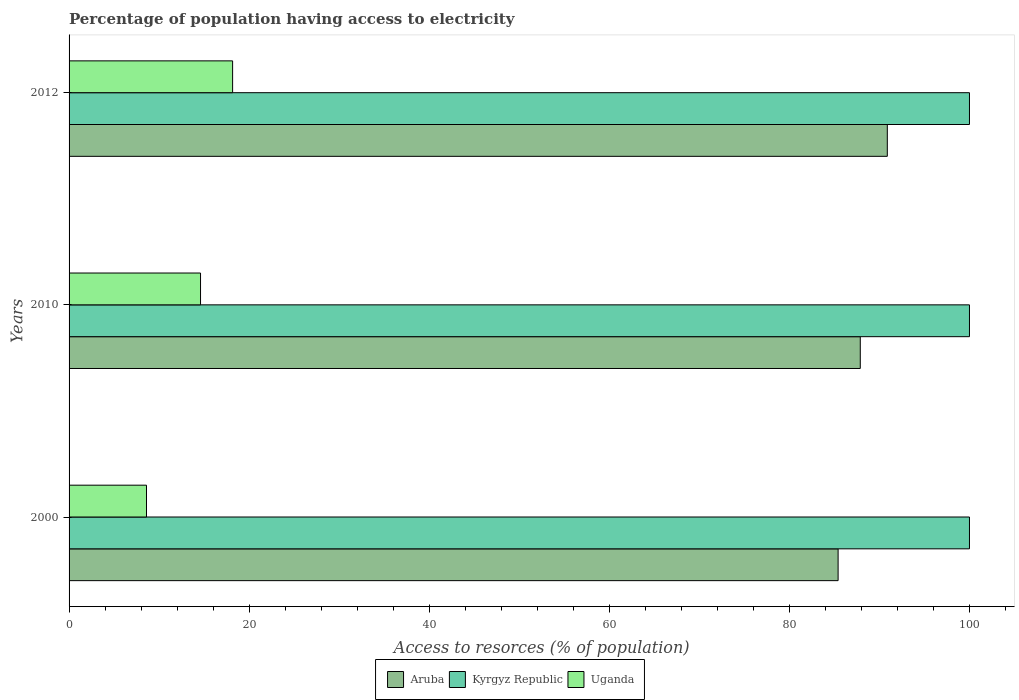How many groups of bars are there?
Provide a succinct answer. 3. Are the number of bars on each tick of the Y-axis equal?
Your response must be concise. Yes. How many bars are there on the 2nd tick from the top?
Provide a succinct answer. 3. How many bars are there on the 3rd tick from the bottom?
Offer a very short reply. 3. What is the label of the 1st group of bars from the top?
Your answer should be very brief. 2012. In how many cases, is the number of bars for a given year not equal to the number of legend labels?
Offer a terse response. 0. What is the percentage of population having access to electricity in Uganda in 2010?
Your answer should be compact. 14.6. Across all years, what is the maximum percentage of population having access to electricity in Uganda?
Keep it short and to the point. 18.16. In which year was the percentage of population having access to electricity in Aruba maximum?
Your answer should be compact. 2012. What is the total percentage of population having access to electricity in Kyrgyz Republic in the graph?
Offer a terse response. 300. What is the difference between the percentage of population having access to electricity in Aruba in 2000 and that in 2012?
Keep it short and to the point. -5.46. What is the difference between the percentage of population having access to electricity in Aruba in 2010 and the percentage of population having access to electricity in Uganda in 2012?
Provide a short and direct response. 69.71. What is the average percentage of population having access to electricity in Kyrgyz Republic per year?
Keep it short and to the point. 100. In the year 2010, what is the difference between the percentage of population having access to electricity in Uganda and percentage of population having access to electricity in Aruba?
Make the answer very short. -73.27. What is the ratio of the percentage of population having access to electricity in Uganda in 2000 to that in 2010?
Provide a short and direct response. 0.59. Is the percentage of population having access to electricity in Uganda in 2000 less than that in 2012?
Offer a very short reply. Yes. Is the difference between the percentage of population having access to electricity in Uganda in 2010 and 2012 greater than the difference between the percentage of population having access to electricity in Aruba in 2010 and 2012?
Offer a terse response. No. What is the difference between the highest and the second highest percentage of population having access to electricity in Aruba?
Your response must be concise. 3. What is the difference between the highest and the lowest percentage of population having access to electricity in Kyrgyz Republic?
Provide a short and direct response. 0. Is the sum of the percentage of population having access to electricity in Kyrgyz Republic in 2000 and 2010 greater than the maximum percentage of population having access to electricity in Aruba across all years?
Your answer should be very brief. Yes. What does the 3rd bar from the top in 2012 represents?
Your answer should be compact. Aruba. What does the 1st bar from the bottom in 2010 represents?
Provide a succinct answer. Aruba. Is it the case that in every year, the sum of the percentage of population having access to electricity in Uganda and percentage of population having access to electricity in Aruba is greater than the percentage of population having access to electricity in Kyrgyz Republic?
Give a very brief answer. No. How many bars are there?
Ensure brevity in your answer.  9. How many years are there in the graph?
Your response must be concise. 3. Are the values on the major ticks of X-axis written in scientific E-notation?
Your answer should be very brief. No. Does the graph contain any zero values?
Your answer should be compact. No. Does the graph contain grids?
Your response must be concise. No. Where does the legend appear in the graph?
Your response must be concise. Bottom center. How many legend labels are there?
Offer a terse response. 3. What is the title of the graph?
Offer a very short reply. Percentage of population having access to electricity. Does "Lebanon" appear as one of the legend labels in the graph?
Offer a terse response. No. What is the label or title of the X-axis?
Provide a short and direct response. Access to resorces (% of population). What is the Access to resorces (% of population) in Aruba in 2000?
Provide a short and direct response. 85.41. What is the Access to resorces (% of population) in Aruba in 2010?
Your response must be concise. 87.87. What is the Access to resorces (% of population) in Kyrgyz Republic in 2010?
Provide a succinct answer. 100. What is the Access to resorces (% of population) in Aruba in 2012?
Offer a terse response. 90.88. What is the Access to resorces (% of population) of Uganda in 2012?
Ensure brevity in your answer.  18.16. Across all years, what is the maximum Access to resorces (% of population) in Aruba?
Provide a short and direct response. 90.88. Across all years, what is the maximum Access to resorces (% of population) of Uganda?
Your answer should be compact. 18.16. Across all years, what is the minimum Access to resorces (% of population) in Aruba?
Provide a succinct answer. 85.41. Across all years, what is the minimum Access to resorces (% of population) in Uganda?
Offer a very short reply. 8.6. What is the total Access to resorces (% of population) in Aruba in the graph?
Your response must be concise. 264.16. What is the total Access to resorces (% of population) in Kyrgyz Republic in the graph?
Your answer should be very brief. 300. What is the total Access to resorces (% of population) in Uganda in the graph?
Give a very brief answer. 41.36. What is the difference between the Access to resorces (% of population) of Aruba in 2000 and that in 2010?
Your answer should be very brief. -2.46. What is the difference between the Access to resorces (% of population) of Uganda in 2000 and that in 2010?
Keep it short and to the point. -6. What is the difference between the Access to resorces (% of population) in Aruba in 2000 and that in 2012?
Your answer should be very brief. -5.46. What is the difference between the Access to resorces (% of population) in Uganda in 2000 and that in 2012?
Give a very brief answer. -9.56. What is the difference between the Access to resorces (% of population) of Aruba in 2010 and that in 2012?
Your answer should be compact. -3. What is the difference between the Access to resorces (% of population) of Kyrgyz Republic in 2010 and that in 2012?
Your answer should be compact. 0. What is the difference between the Access to resorces (% of population) in Uganda in 2010 and that in 2012?
Offer a very short reply. -3.56. What is the difference between the Access to resorces (% of population) in Aruba in 2000 and the Access to resorces (% of population) in Kyrgyz Republic in 2010?
Provide a short and direct response. -14.59. What is the difference between the Access to resorces (% of population) in Aruba in 2000 and the Access to resorces (% of population) in Uganda in 2010?
Ensure brevity in your answer.  70.81. What is the difference between the Access to resorces (% of population) in Kyrgyz Republic in 2000 and the Access to resorces (% of population) in Uganda in 2010?
Your response must be concise. 85.4. What is the difference between the Access to resorces (% of population) of Aruba in 2000 and the Access to resorces (% of population) of Kyrgyz Republic in 2012?
Provide a succinct answer. -14.59. What is the difference between the Access to resorces (% of population) of Aruba in 2000 and the Access to resorces (% of population) of Uganda in 2012?
Keep it short and to the point. 67.25. What is the difference between the Access to resorces (% of population) in Kyrgyz Republic in 2000 and the Access to resorces (% of population) in Uganda in 2012?
Offer a terse response. 81.84. What is the difference between the Access to resorces (% of population) in Aruba in 2010 and the Access to resorces (% of population) in Kyrgyz Republic in 2012?
Give a very brief answer. -12.13. What is the difference between the Access to resorces (% of population) in Aruba in 2010 and the Access to resorces (% of population) in Uganda in 2012?
Give a very brief answer. 69.71. What is the difference between the Access to resorces (% of population) in Kyrgyz Republic in 2010 and the Access to resorces (% of population) in Uganda in 2012?
Your answer should be compact. 81.84. What is the average Access to resorces (% of population) of Aruba per year?
Your answer should be very brief. 88.05. What is the average Access to resorces (% of population) in Kyrgyz Republic per year?
Ensure brevity in your answer.  100. What is the average Access to resorces (% of population) in Uganda per year?
Your response must be concise. 13.79. In the year 2000, what is the difference between the Access to resorces (% of population) of Aruba and Access to resorces (% of population) of Kyrgyz Republic?
Provide a succinct answer. -14.59. In the year 2000, what is the difference between the Access to resorces (% of population) in Aruba and Access to resorces (% of population) in Uganda?
Give a very brief answer. 76.81. In the year 2000, what is the difference between the Access to resorces (% of population) of Kyrgyz Republic and Access to resorces (% of population) of Uganda?
Make the answer very short. 91.4. In the year 2010, what is the difference between the Access to resorces (% of population) of Aruba and Access to resorces (% of population) of Kyrgyz Republic?
Your response must be concise. -12.13. In the year 2010, what is the difference between the Access to resorces (% of population) in Aruba and Access to resorces (% of population) in Uganda?
Give a very brief answer. 73.27. In the year 2010, what is the difference between the Access to resorces (% of population) of Kyrgyz Republic and Access to resorces (% of population) of Uganda?
Ensure brevity in your answer.  85.4. In the year 2012, what is the difference between the Access to resorces (% of population) of Aruba and Access to resorces (% of population) of Kyrgyz Republic?
Your answer should be compact. -9.12. In the year 2012, what is the difference between the Access to resorces (% of population) of Aruba and Access to resorces (% of population) of Uganda?
Your answer should be compact. 72.71. In the year 2012, what is the difference between the Access to resorces (% of population) of Kyrgyz Republic and Access to resorces (% of population) of Uganda?
Your response must be concise. 81.84. What is the ratio of the Access to resorces (% of population) of Aruba in 2000 to that in 2010?
Ensure brevity in your answer.  0.97. What is the ratio of the Access to resorces (% of population) in Kyrgyz Republic in 2000 to that in 2010?
Make the answer very short. 1. What is the ratio of the Access to resorces (% of population) in Uganda in 2000 to that in 2010?
Your response must be concise. 0.59. What is the ratio of the Access to resorces (% of population) in Aruba in 2000 to that in 2012?
Your response must be concise. 0.94. What is the ratio of the Access to resorces (% of population) in Uganda in 2000 to that in 2012?
Ensure brevity in your answer.  0.47. What is the ratio of the Access to resorces (% of population) in Uganda in 2010 to that in 2012?
Keep it short and to the point. 0.8. What is the difference between the highest and the second highest Access to resorces (% of population) of Aruba?
Provide a short and direct response. 3. What is the difference between the highest and the second highest Access to resorces (% of population) in Uganda?
Offer a very short reply. 3.56. What is the difference between the highest and the lowest Access to resorces (% of population) of Aruba?
Offer a very short reply. 5.46. What is the difference between the highest and the lowest Access to resorces (% of population) of Kyrgyz Republic?
Offer a very short reply. 0. What is the difference between the highest and the lowest Access to resorces (% of population) of Uganda?
Provide a short and direct response. 9.56. 